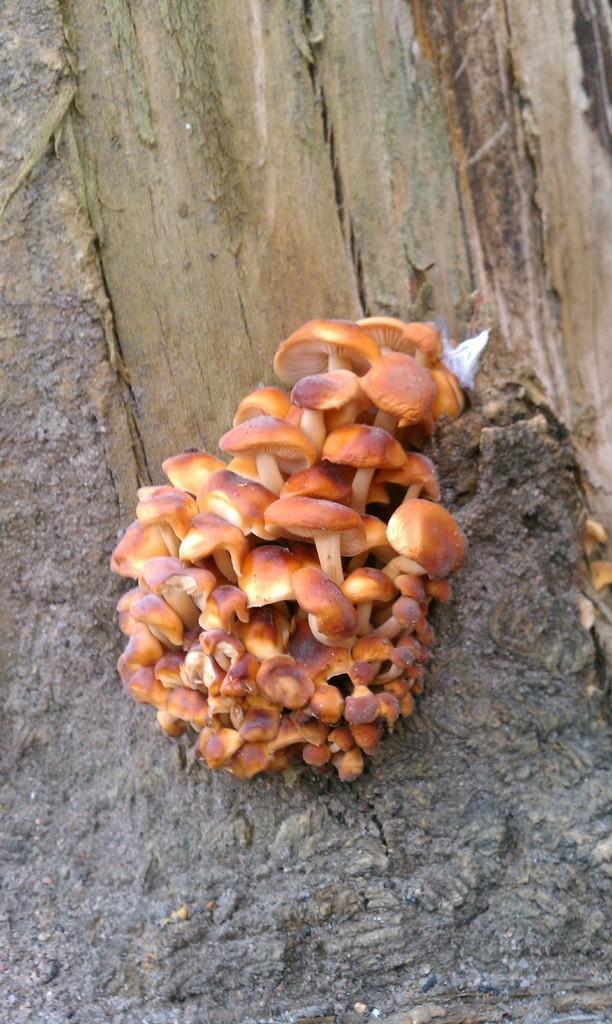Please provide a concise description of this image. In the center of the image we can see a few mushrooms. In the background there is a wooden object. 